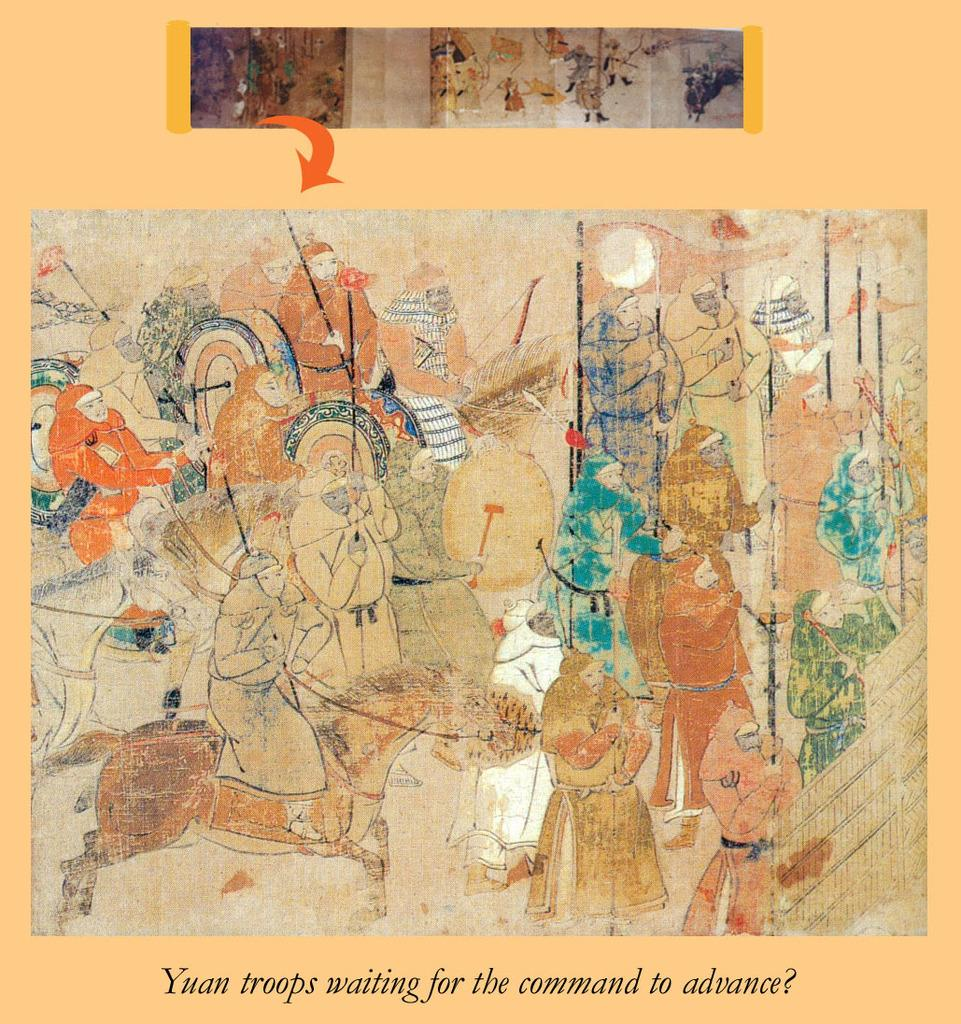What is the main subject in the image? There is a painted board in the image. What can be seen on the painted board? There is text visible on the painted board. How many sisters are depicted on the painted board in the image? There is no mention of sisters on the painted board in the image. What type of print is used for the text on the painted board? The facts provided do not specify the type of print used for the text on the painted board. 